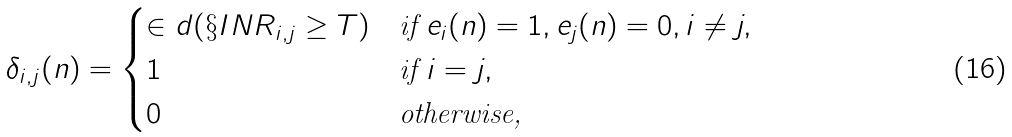<formula> <loc_0><loc_0><loc_500><loc_500>\delta _ { i , j } ( n ) = \begin{cases} \in d ( \S I N R _ { i , j } \geq T ) & \text {if} \ e _ { i } ( n ) = 1 , e _ { j } ( n ) = 0 , i \not = j , \\ 1 & \text {if} \ i = j , \\ 0 & \text {otherwise,} \end{cases}</formula> 